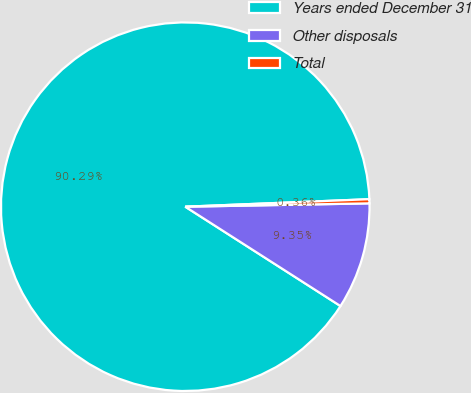Convert chart. <chart><loc_0><loc_0><loc_500><loc_500><pie_chart><fcel>Years ended December 31<fcel>Other disposals<fcel>Total<nl><fcel>90.29%<fcel>9.35%<fcel>0.36%<nl></chart> 